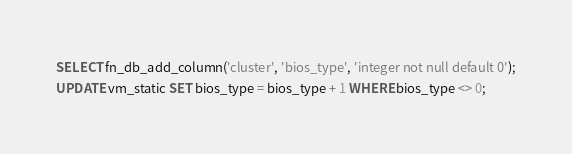Convert code to text. <code><loc_0><loc_0><loc_500><loc_500><_SQL_>SELECT fn_db_add_column('cluster', 'bios_type', 'integer not null default 0');
UPDATE vm_static SET bios_type = bios_type + 1 WHERE bios_type <> 0;
</code> 